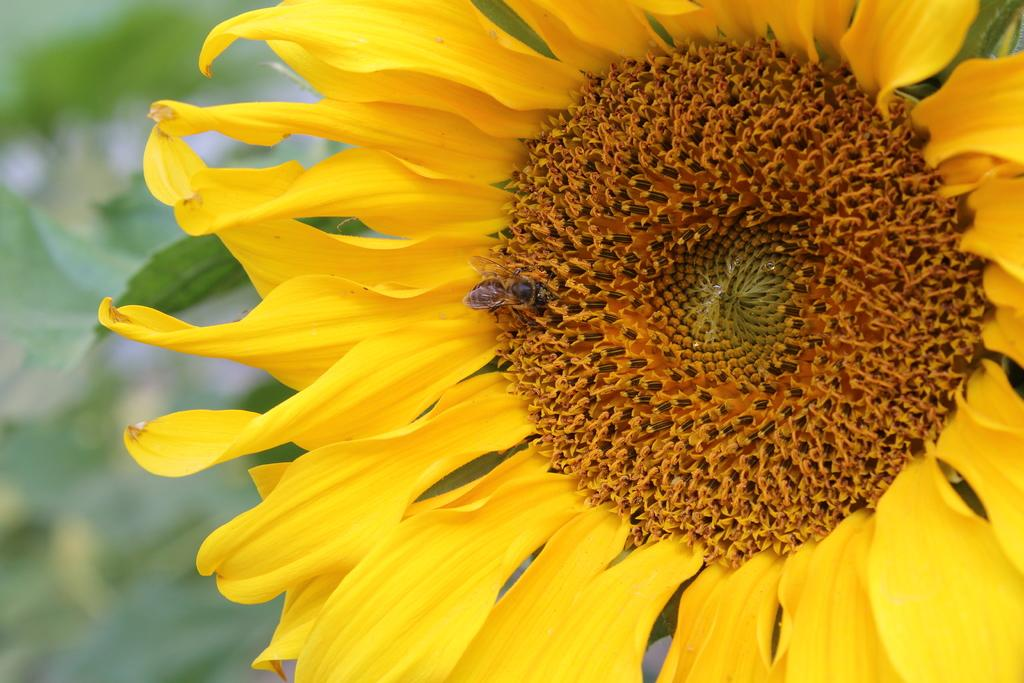What is the main subject of the image? The main subject of the image is a fly. Where is the fly located in the image? The fly is on a sunflower. How many girls are visible in the image? There are no girls present in the image; it features a fly on a sunflower. What type of creature is shown interacting with the fly in the image? There is no creature shown interacting with the fly in the image; only the fly and the sunflower are present. 